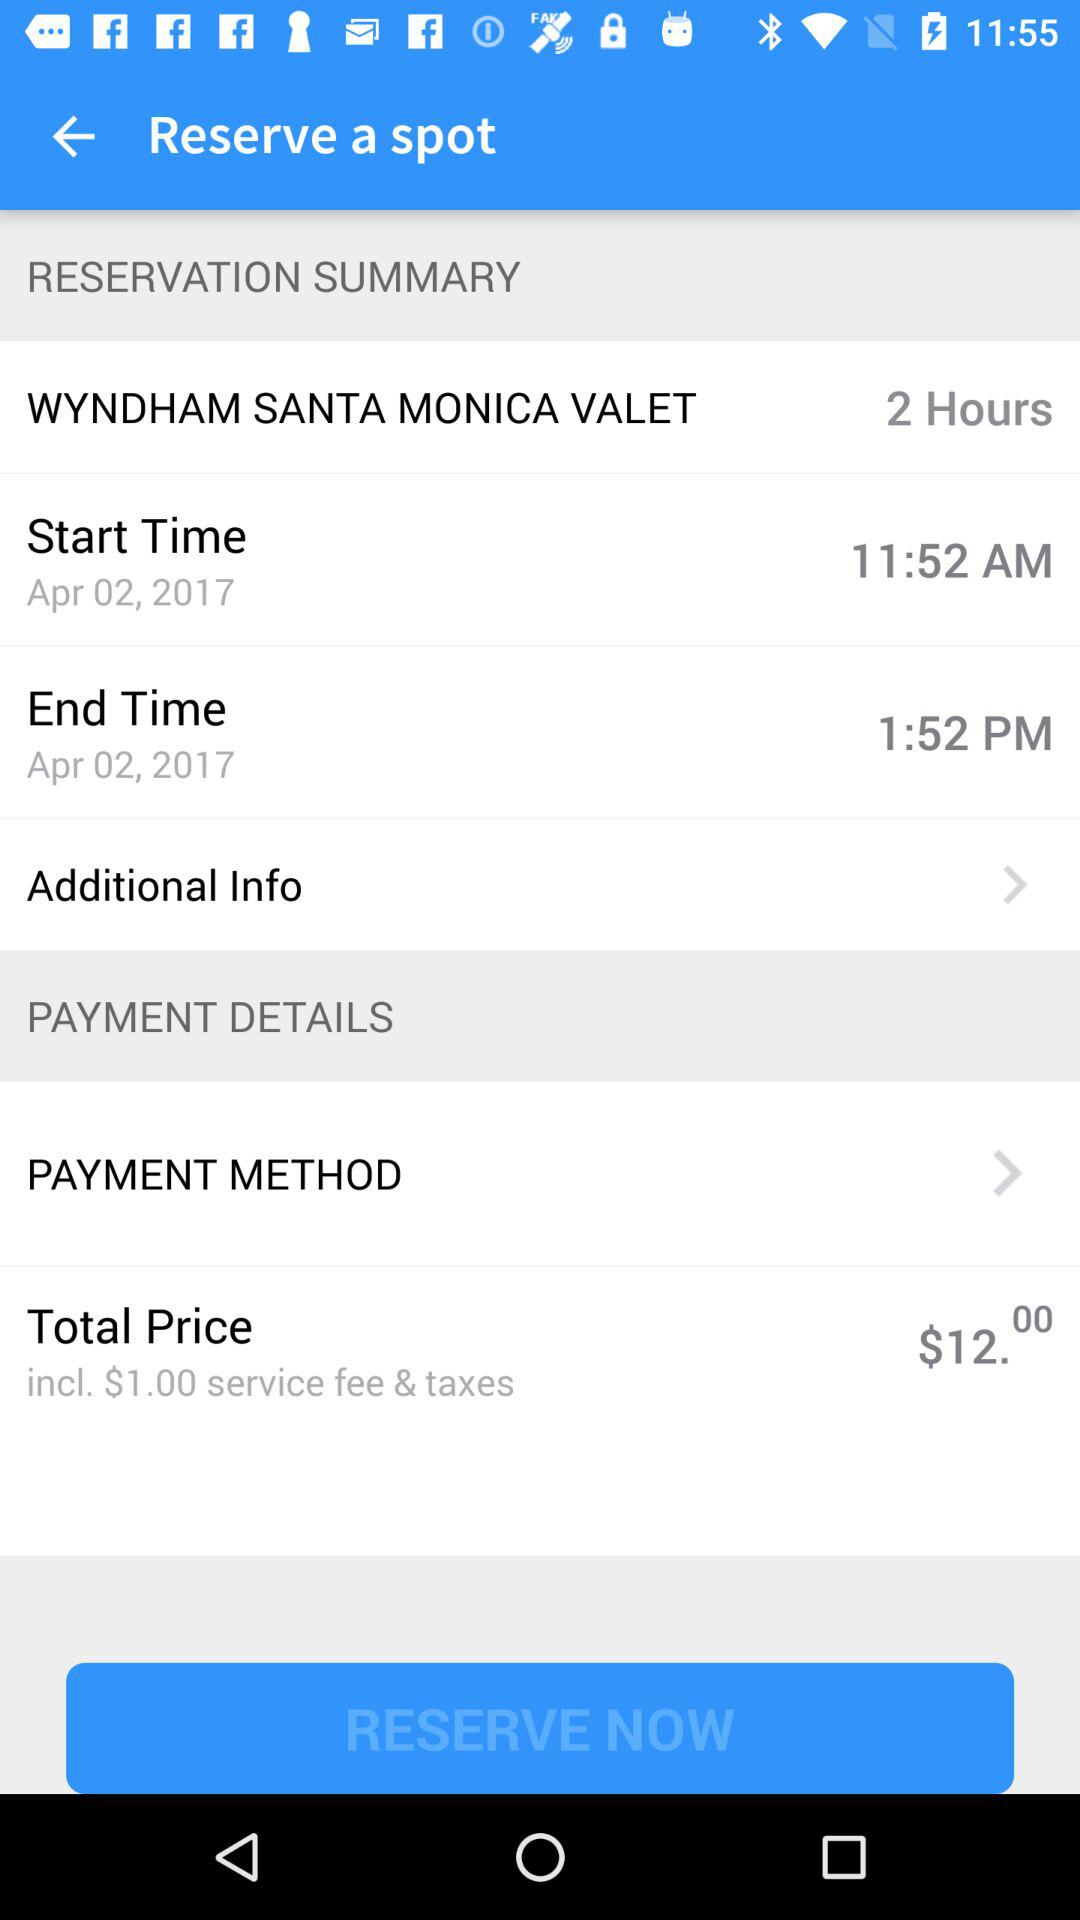Where is the spot reserved? The spot is reserved at the Wyndham Santa Monica. 